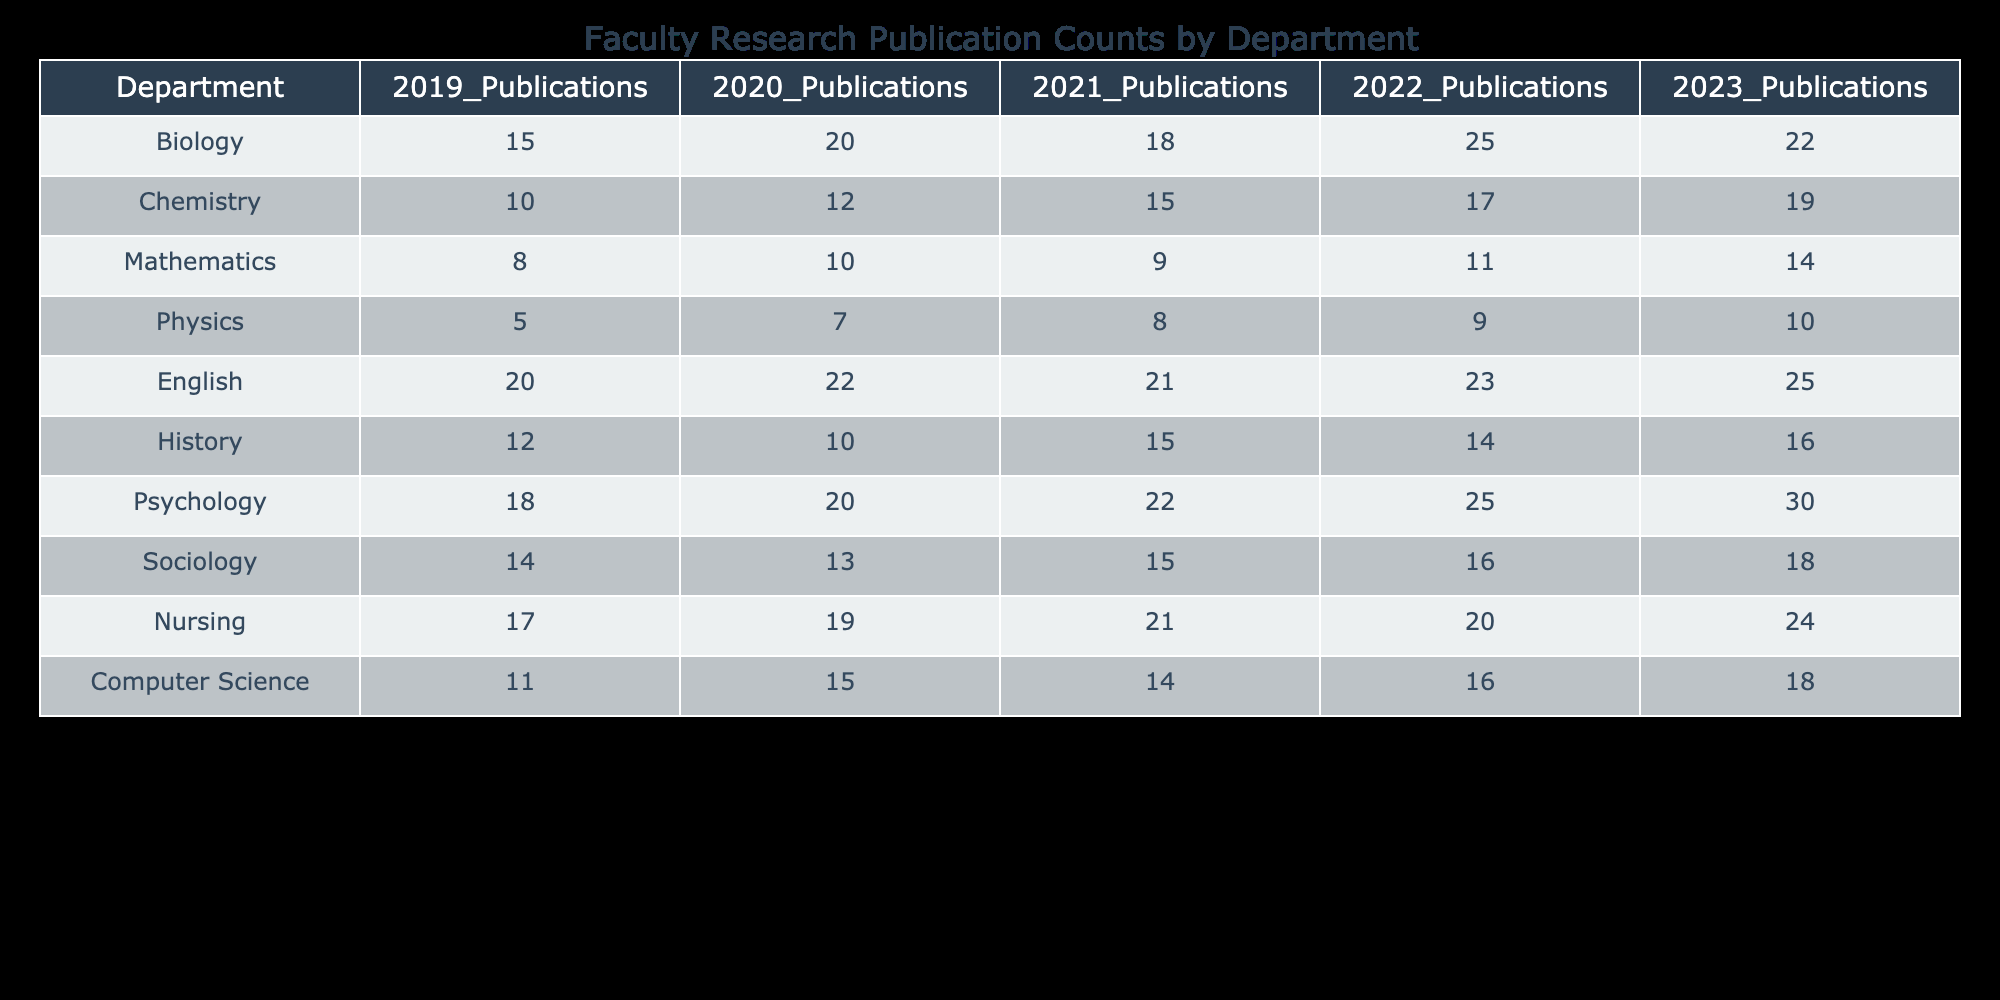What is the total number of publications in the Psychology department in 2022? The table shows that the Psychology department had 25 publications in 2022.
Answer: 25 Which department had the highest number of publications in 2023? By comparing the values in the 2023 column, Psychology has 30 publications, which is the highest among all departments.
Answer: Psychology What is the average number of publications for the Biology department over the last five years? The total publications for Biology over five years is 15 + 20 + 18 + 25 + 22 = 100. To find the average, we divide by 5 (100/5 = 20).
Answer: 20 Did the Nursing department have more publications in 2023 than in 2020? In 2023, the Nursing department had 24 publications and in 2020, it had 19. Therefore, 24 is greater than 19, making this statement true.
Answer: Yes What is the difference in publication counts for the Chemistry department between 2019 and 2023? The Chemistry department had 10 publications in 2019 and 19 in 2023. The difference is 19 - 10 = 9.
Answer: 9 Which department had a steady increase in publication counts every year? Analyzing the publication counts for each department, Psychology consistently increased from 18 in 2019 to 30 in 2023 without any decrease.
Answer: Psychology What are the total publications in the English department from 2019 to 2023? The English department had 20 + 22 + 21 + 23 + 25 = 111 publications over the five years.
Answer: 111 Did the Sociology department ever exceed 15 publications in any of the last five years? Checking the Sociology department's counts, it had 14 in 2019, 13 in 2020, 15 in 2021, 16 in 2022, and 18 in 2023, confirming that it exceeded 15 in 2022 and 2023.
Answer: Yes What is the median number of publications in the Physics department over the five years? The publication counts for Physics are 5, 7, 8, 9, and 10. When arranged, the middle value (the third number) is 8, which is the median.
Answer: 8 